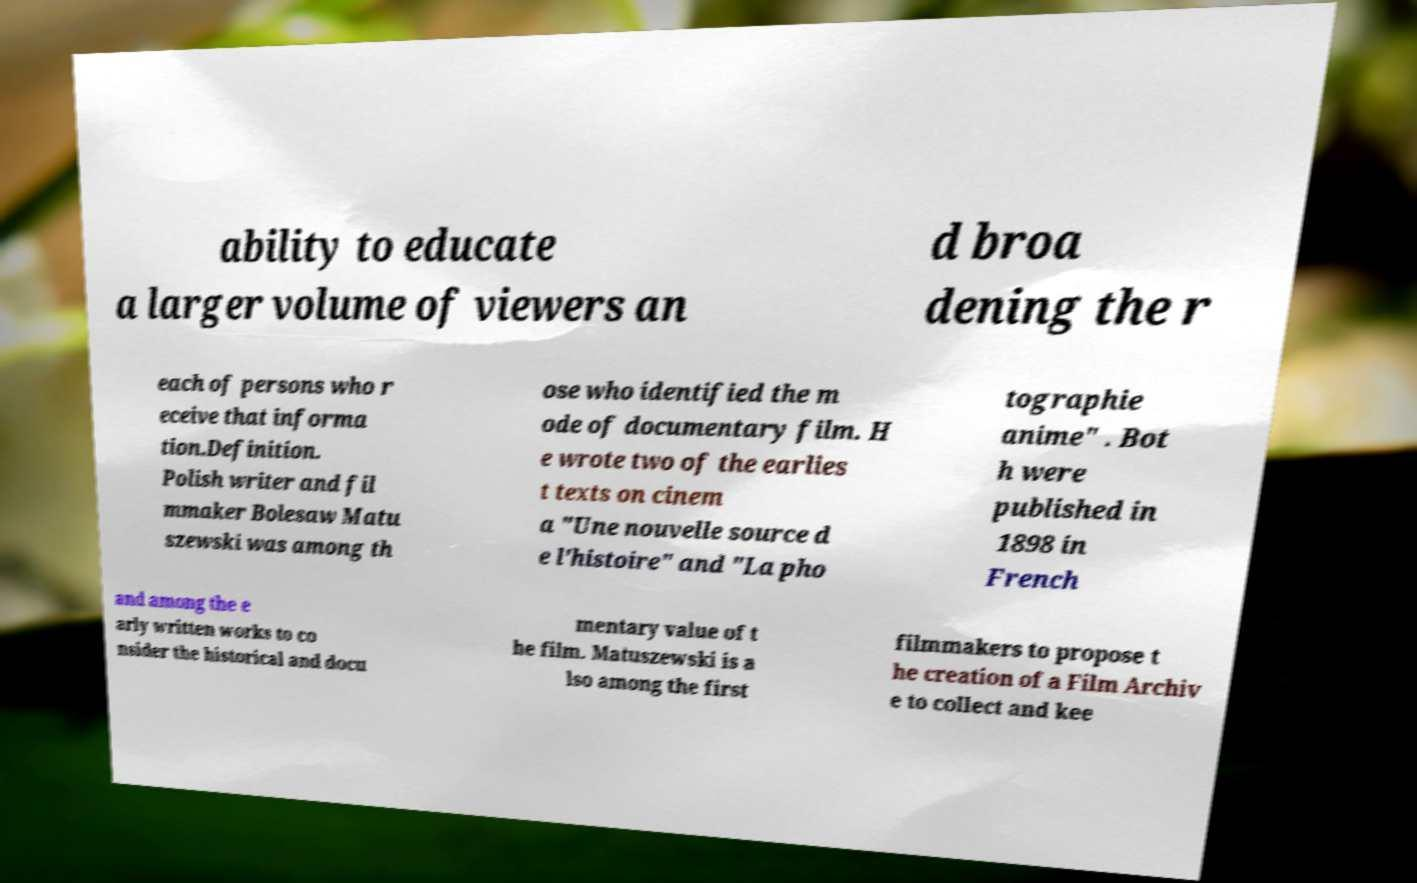There's text embedded in this image that I need extracted. Can you transcribe it verbatim? ability to educate a larger volume of viewers an d broa dening the r each of persons who r eceive that informa tion.Definition. Polish writer and fil mmaker Bolesaw Matu szewski was among th ose who identified the m ode of documentary film. H e wrote two of the earlies t texts on cinem a "Une nouvelle source d e l'histoire" and "La pho tographie anime" . Bot h were published in 1898 in French and among the e arly written works to co nsider the historical and docu mentary value of t he film. Matuszewski is a lso among the first filmmakers to propose t he creation of a Film Archiv e to collect and kee 